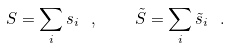Convert formula to latex. <formula><loc_0><loc_0><loc_500><loc_500>S = \sum _ { i } s _ { i } \ , \quad \tilde { S } = \sum _ { i } \tilde { s } _ { i } \ .</formula> 